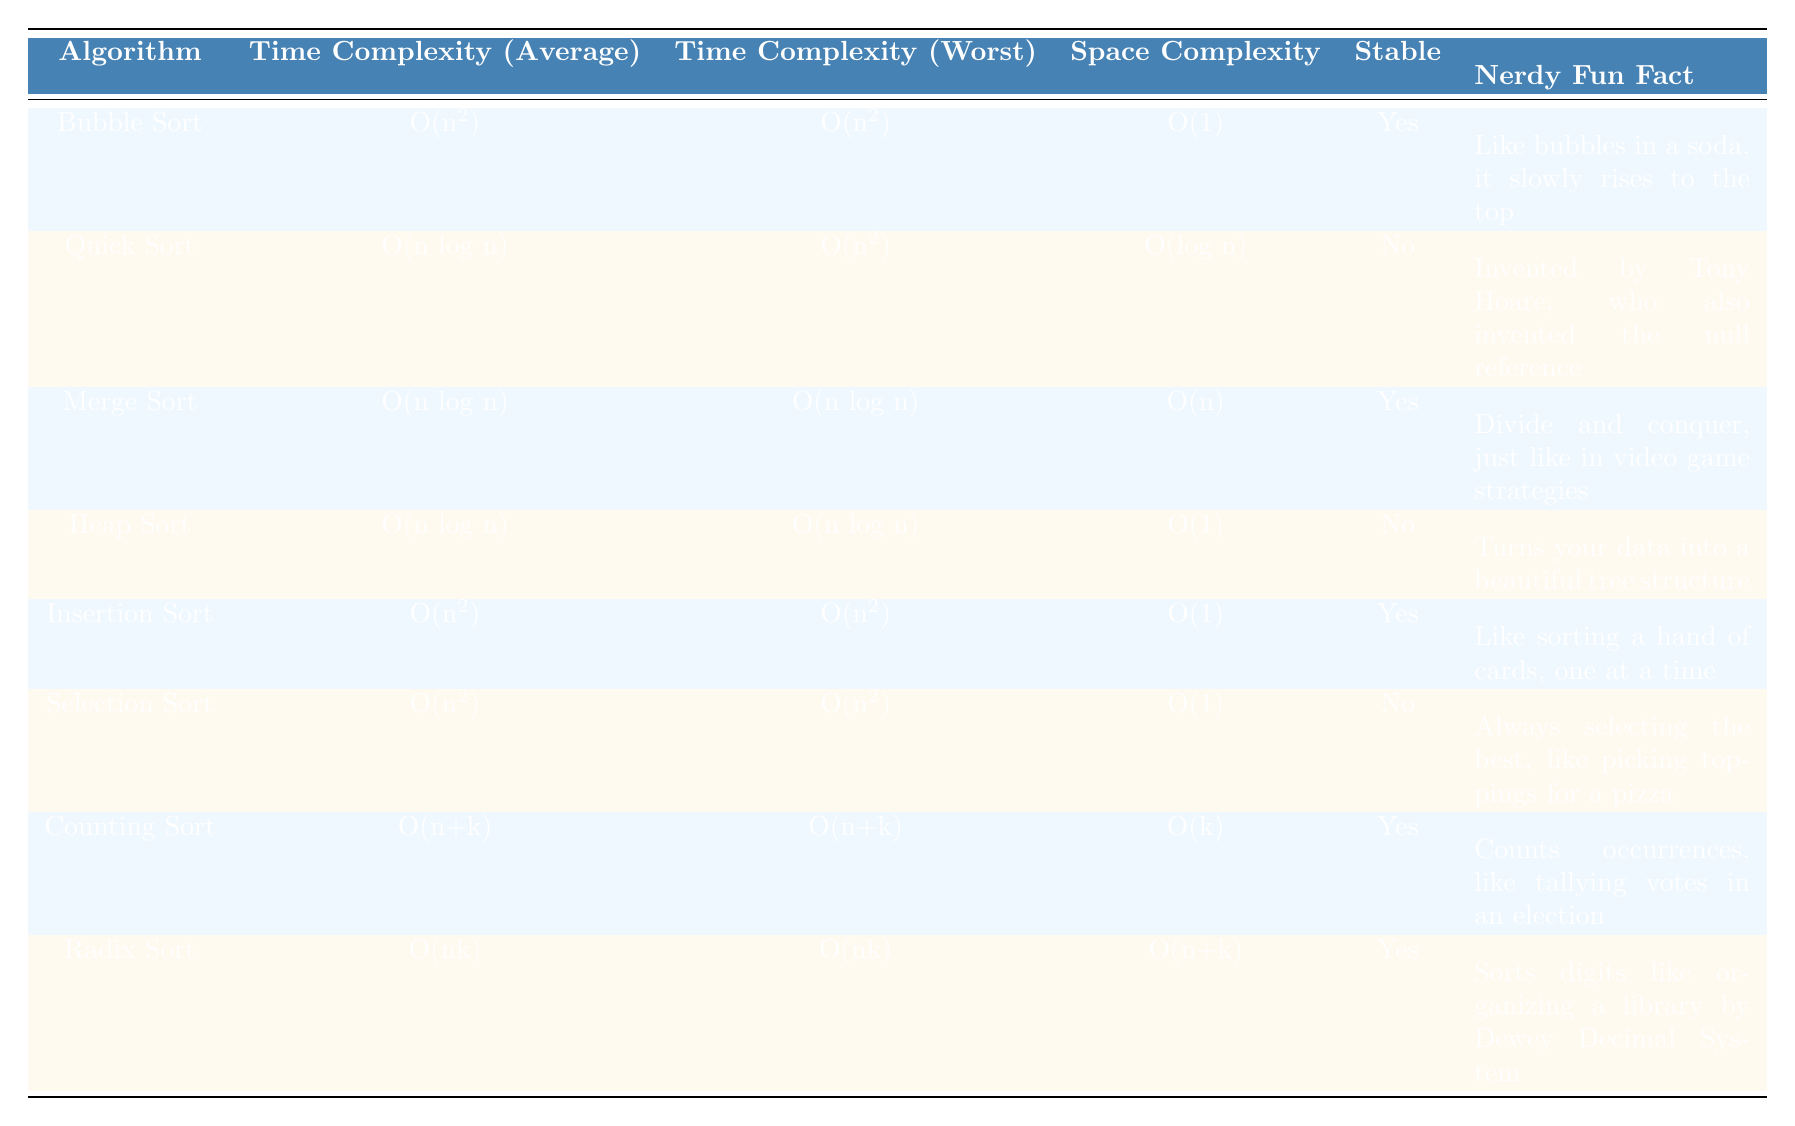What is the time complexity of Bubble Sort in the average case? According to the table, the time complexity of Bubble Sort in the average case is listed under the "Time Complexity (Average)" column. It states "O(n^2)", which summarizes its performance for average inputs.
Answer: O(n^2) Which sorting algorithm has the lowest space complexity? Observing the "Space Complexity" column, we see that both Bubble Sort, Insertion Sort, and Selection Sort have a space complexity of O(1). However, the question asks for the lowest; hence all these algorithms meet that criterion, but they are tied.
Answer: O(1) Is Quick Sort a stable sorting algorithm? The "Stable" column clearly indicates whether an algorithm is stable or not. For Quick Sort, it is marked as "No", indicating that Quick Sort does not maintain the relative order of equal elements.
Answer: No Which algorithms have an average time complexity of O(n log n)? Looking at the "Time Complexity (Average)" column, the algorithms with O(n log n) complexity appear to be Quick Sort, Merge Sort, and Heap Sort. All these algorithms are noted for their efficiency on average cases, making them suitable for larger datasets.
Answer: Quick Sort, Merge Sort, Heap Sort If you combine the average time complexities of Counting Sort and Radix Sort, what do you get? To find the combined average time complexities, we take the complexities from the table: Counting Sort is O(n+k) and Radix Sort is O(nk). However, as they represent different forms of complexities, we cannot directly sum them. Instead, we can simply acknowledge they both have linear components (n) but also include other parameters (k), making this more a qualitative observation than a numerical sum.
Answer: O(n+k) and O(nk) Which algorithm is specifically designed to count occurrences in order to sort? The table identifies Counting Sort as specifically designed to count occurrences, which explains its unique functionality for sorting efficiently by tallying values.
Answer: Counting Sort Does Merge Sort have the same time complexity for average and worst cases? By reviewing the "Time Complexity (Average)" and "Time Complexity (Worst)" columns for Merge Sort, we can see both are listed as O(n log n). Therefore, it does have the same time complexity in these two scenarios, maintaining the efficiency across all inputs.
Answer: Yes How many algorithms are stable based on the table? By checking the "Stable" column, we can identify which algorithms are stable by counting the "Yes" responses. From the table, we have Bubble Sort, Merge Sort, Insertion Sort, Counting Sort, and Radix Sort, totaling five stable algorithms.
Answer: 5 If we consider the worst-case time complexities, which two algorithms share the same level of efficiency? Focusing on the "Time Complexity (Worst)" column, we see that Quick Sort and Selection Sort both share the O(n^2) worst-case complexity. This highlights important considerations related to performance under adverse conditions.
Answer: Quick Sort and Selection Sort 